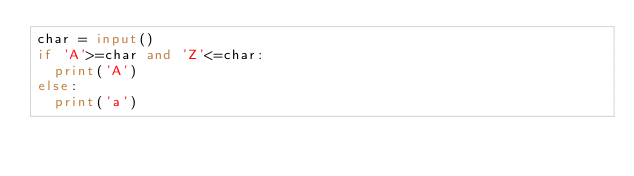Convert code to text. <code><loc_0><loc_0><loc_500><loc_500><_Python_>char = input()
if 'A'>=char and 'Z'<=char:
  print('A')
else:
  print('a')</code> 